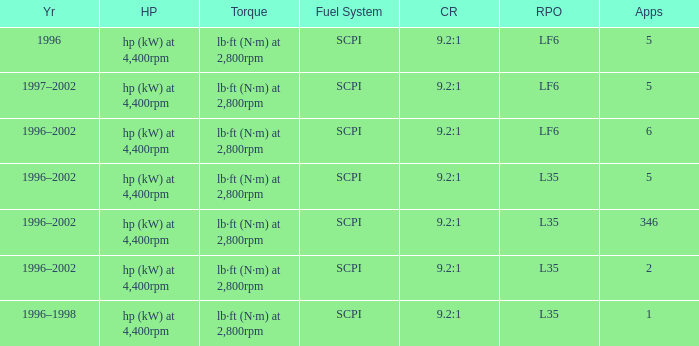What are the torque characteristics of the model with 346 applications? Lb·ft (n·m) at 2,800rpm. 